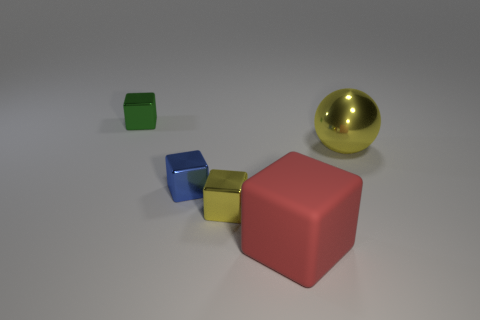Add 4 yellow metallic balls. How many objects exist? 9 Subtract all spheres. How many objects are left? 4 Add 4 tiny yellow metal cubes. How many tiny yellow metal cubes exist? 5 Subtract 0 brown cylinders. How many objects are left? 5 Subtract all tiny green shiny cubes. Subtract all blue rubber blocks. How many objects are left? 4 Add 4 red rubber things. How many red rubber things are left? 5 